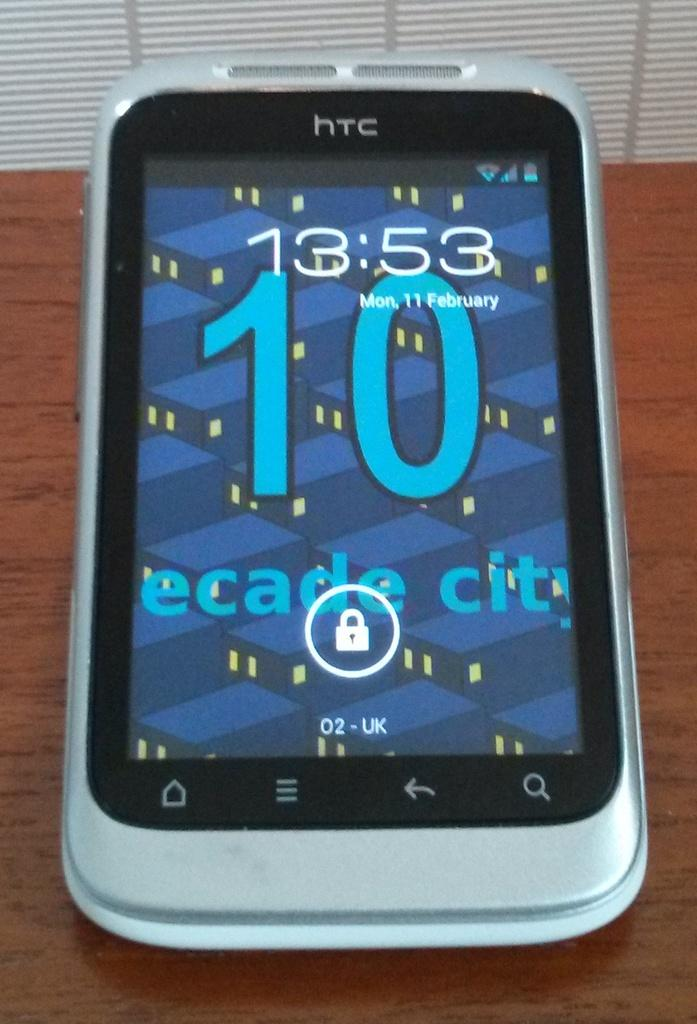<image>
Describe the image concisely. The lock screen for an HTC phone is displayed. 